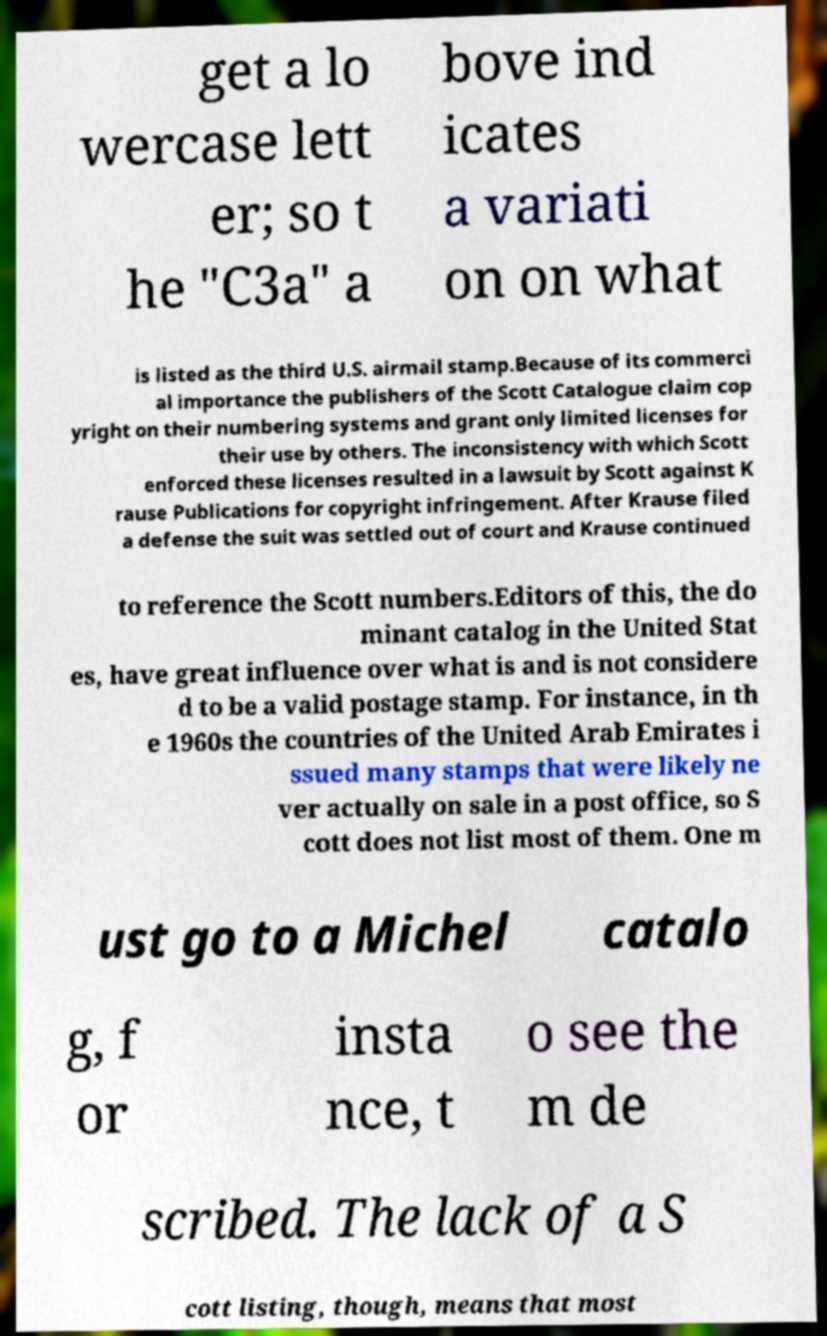I need the written content from this picture converted into text. Can you do that? get a lo wercase lett er; so t he "C3a" a bove ind icates a variati on on what is listed as the third U.S. airmail stamp.Because of its commerci al importance the publishers of the Scott Catalogue claim cop yright on their numbering systems and grant only limited licenses for their use by others. The inconsistency with which Scott enforced these licenses resulted in a lawsuit by Scott against K rause Publications for copyright infringement. After Krause filed a defense the suit was settled out of court and Krause continued to reference the Scott numbers.Editors of this, the do minant catalog in the United Stat es, have great influence over what is and is not considere d to be a valid postage stamp. For instance, in th e 1960s the countries of the United Arab Emirates i ssued many stamps that were likely ne ver actually on sale in a post office, so S cott does not list most of them. One m ust go to a Michel catalo g, f or insta nce, t o see the m de scribed. The lack of a S cott listing, though, means that most 